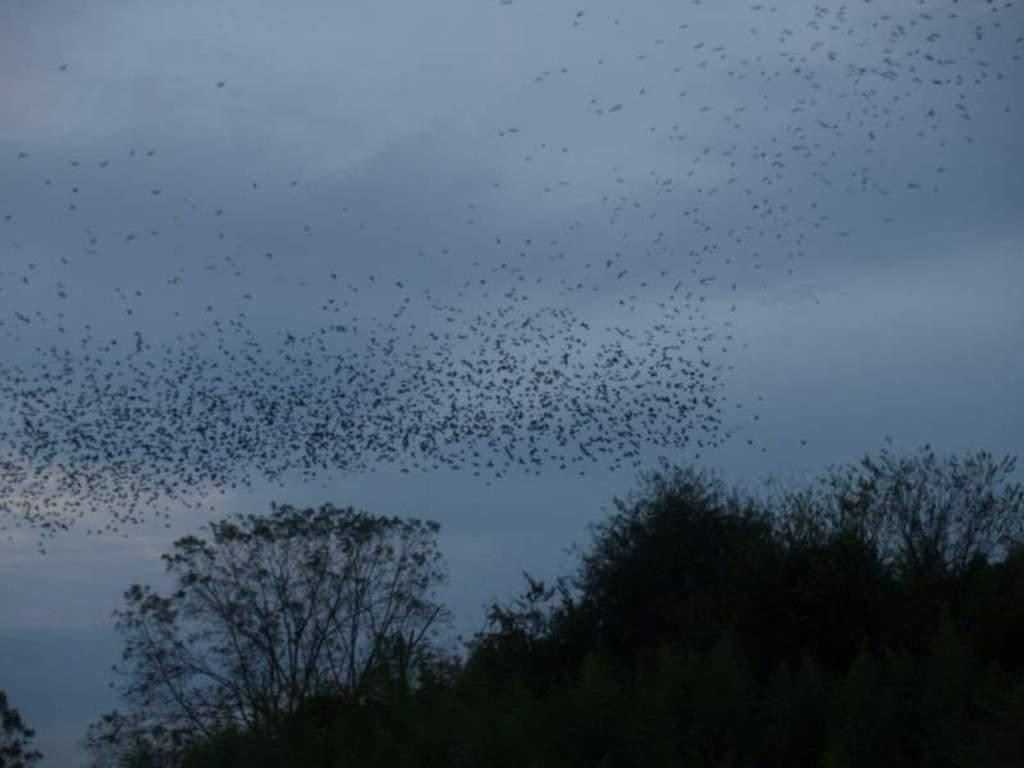What type of vegetation is present in the image? There are trees in the image. What animals can be seen in the image? There is a group of birds flying in the image. How would you describe the sky in the image? The sky is blue and cloudy in the image. Where is the box located in the image? There is no box present in the image. Can you see any rail tracks in the image? There are no rail tracks visible in the image. 